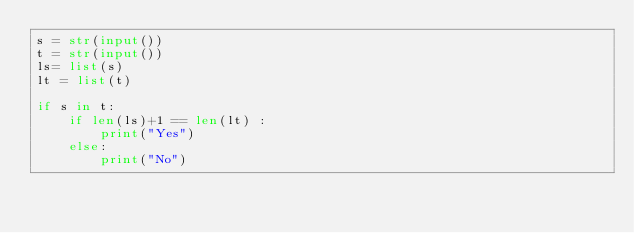Convert code to text. <code><loc_0><loc_0><loc_500><loc_500><_Python_>s = str(input())
t = str(input())
ls= list(s)
lt = list(t)
 
if s in t:
	if len(ls)+1 == len(lt) :
		print("Yes")
	else:
	    print("No")</code> 